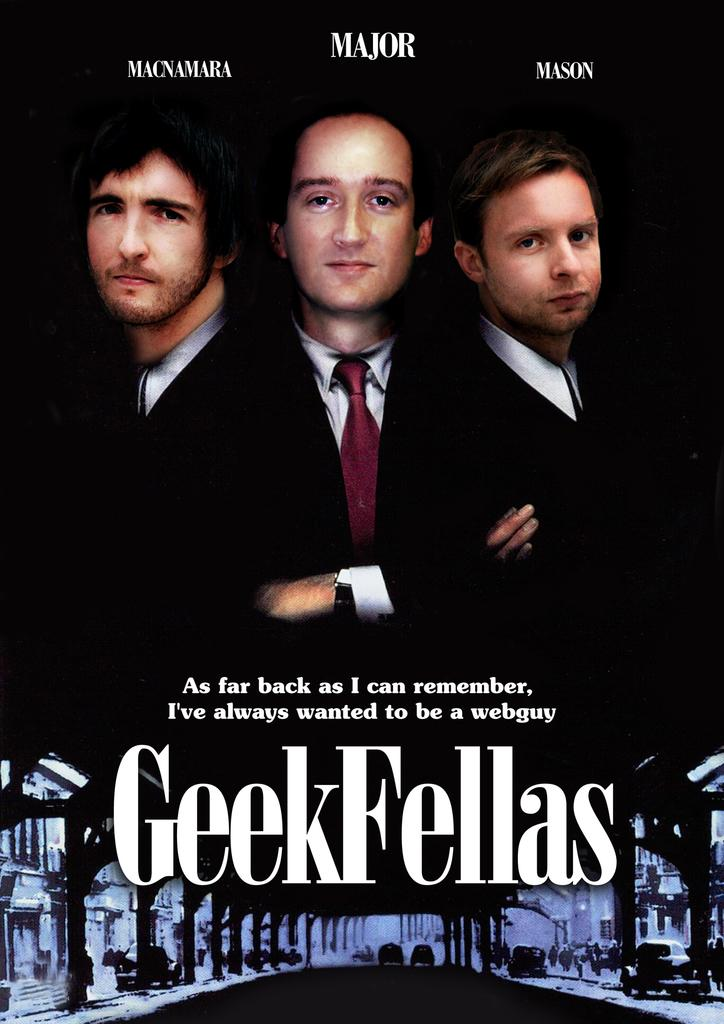What is present on the poster in the image? The poster contains text and images. Can you describe the content of the poster in more detail? Unfortunately, the specific content of the poster cannot be determined from the provided facts. How does the poster express its approval of the new policy? There is no indication in the image that the poster is expressing approval of any policy, as the content of the poster is not specified. 